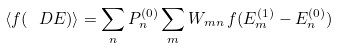Convert formula to latex. <formula><loc_0><loc_0><loc_500><loc_500>\langle f ( \ D E ) \rangle = \sum _ { n } P _ { n } ^ { ( 0 ) } \sum _ { m } W _ { m n } \, f ( E _ { m } ^ { ( 1 ) } - E _ { n } ^ { ( 0 ) } )</formula> 